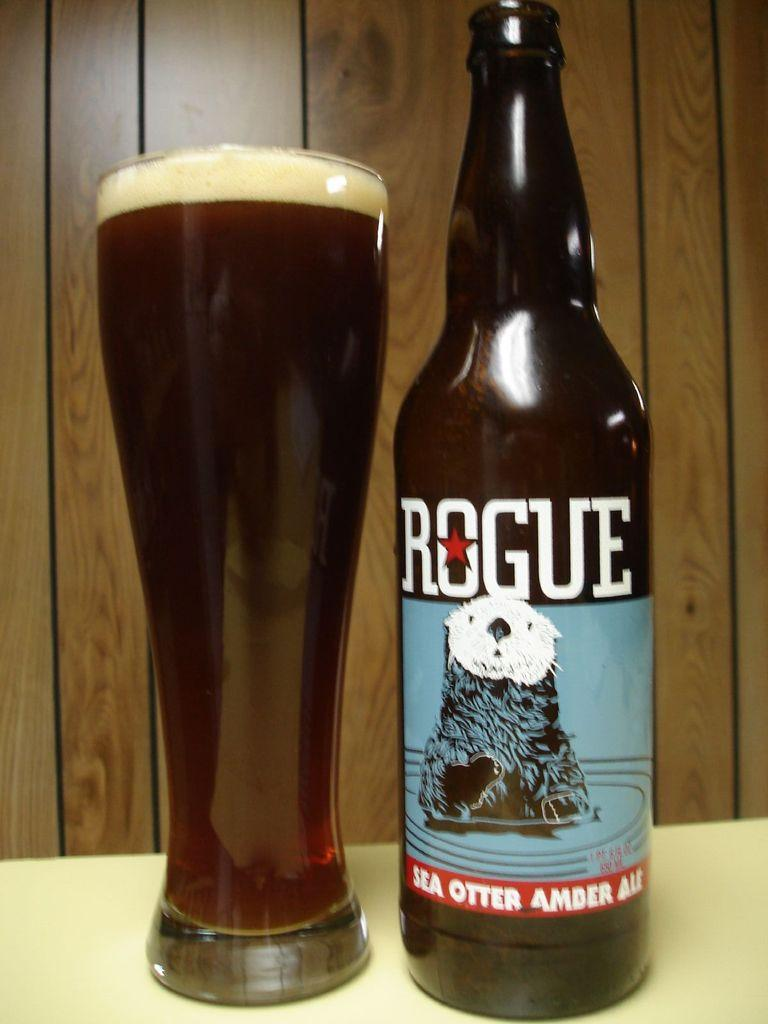<image>
Present a compact description of the photo's key features. A Rouge beer bottle next to a full glass of beer. 